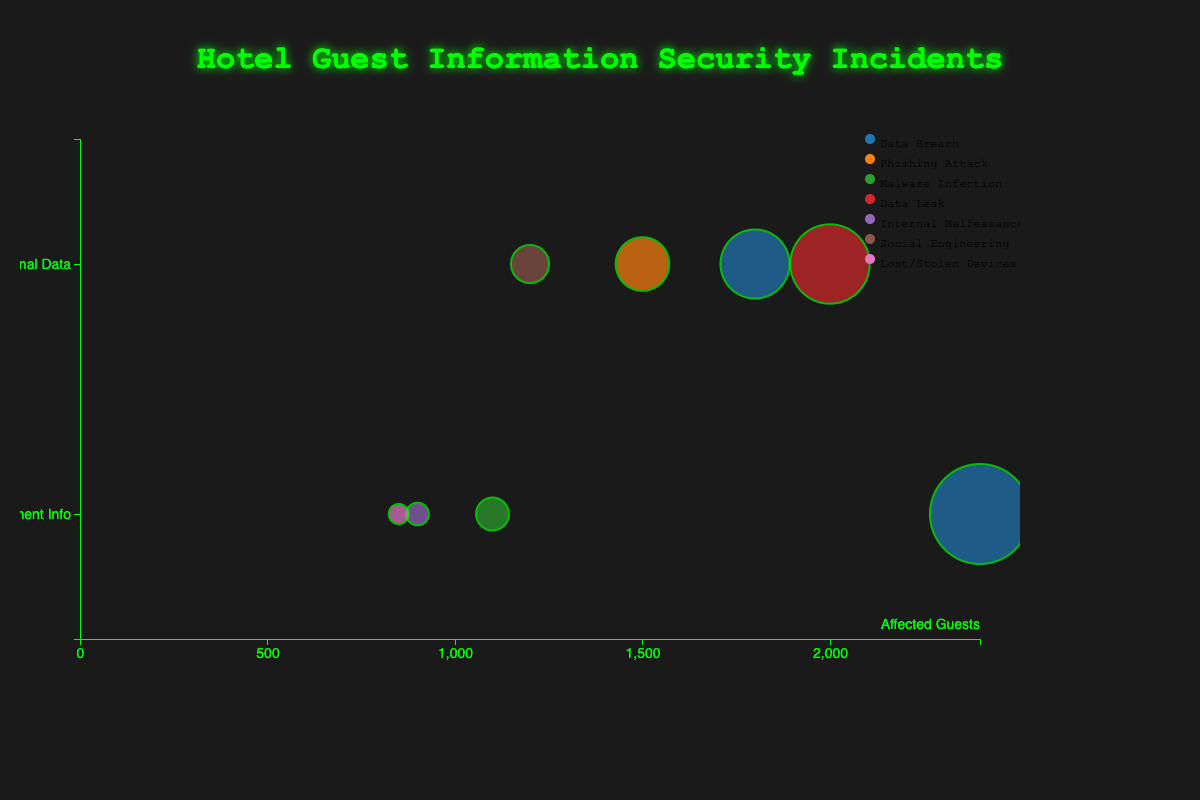What is the title of the bubble chart? The title of the bubble chart is usually found at the top of the chart, and in this case, it reads "Hotel Guest Information Security Incidents".
Answer: Hotel Guest Information Security Incidents How many different categories of guest information are represented on the Y-axis? On the Y-axis, we see distinct points representing the categories "Payment Info" and "Personal Data". The number of these unique points gives us the total number of categories.
Answer: 2 Which hotel had the highest number of affected guests due to a single incident? By examining the bubble sizes and labels, the largest bubble corresponds to "Marriott International" with a "Data Breach" affecting 2400 guests.
Answer: Marriott International What color is used to denote "Data Breach" incidents? To find out the color denoting "Data Breach" incidents, we look at the legend alongside the different colored bubbles. The color linked to "Data Breach" should be accordingly identified.
Answer: This depends on the color scheme used in the actual chart, often a specific color like blue, checked within the provided chart How many guests were affected by "Malware Infection" incidents? To get the number of affected guests from "Malware Infection," we locate the "Malware Infection" bubble and read the associated numerical value. Specifically, look for "Malware Infection" incident type on the legend and corresponding bubble size.
Answer: 1100 Compare the number of affected guests between "Marriott International" and "Hyatt Hotels". Which one had more guests affected and by how much? "Marriott International" had 2400 guests affected, and "Hyatt Hotels" had 1100 guests affected. Subtract the smaller number from the larger number to find the difference: 2400 - 1100 = 1300.
Answer: Marriott International had 1300 more guests affected What is the average number of guests affected by incidents categorized under "Payment Info"? Calculate the total number of guests affected within the "Payment Info" category: 2400 (Data Breach) + 1100 (Malware Infection) + 900 (Internal Malfeasance) + 850 (Lost/Stolen Devices) = 5250. There are 4 incidents, so the average is 5250 / 4.
Answer: 1312.5 Which incident type impacted the most guests overall? To determine which incident type impacted the most guests, sum the affected guests for each specific incident type and compare them. The data suggest reviewing each incident type's total impacts.
Answer: Data Breach Is the impact level always related to a higher number of affected guests? For example, do "High" impact levels always represent larger bubbles? Examine the bubbles with different impact levels ("High", "Medium", "Low") and compare their sizes to see if higher impact levels correlate with larger numbers of affected guests.
Answer: No, not always 